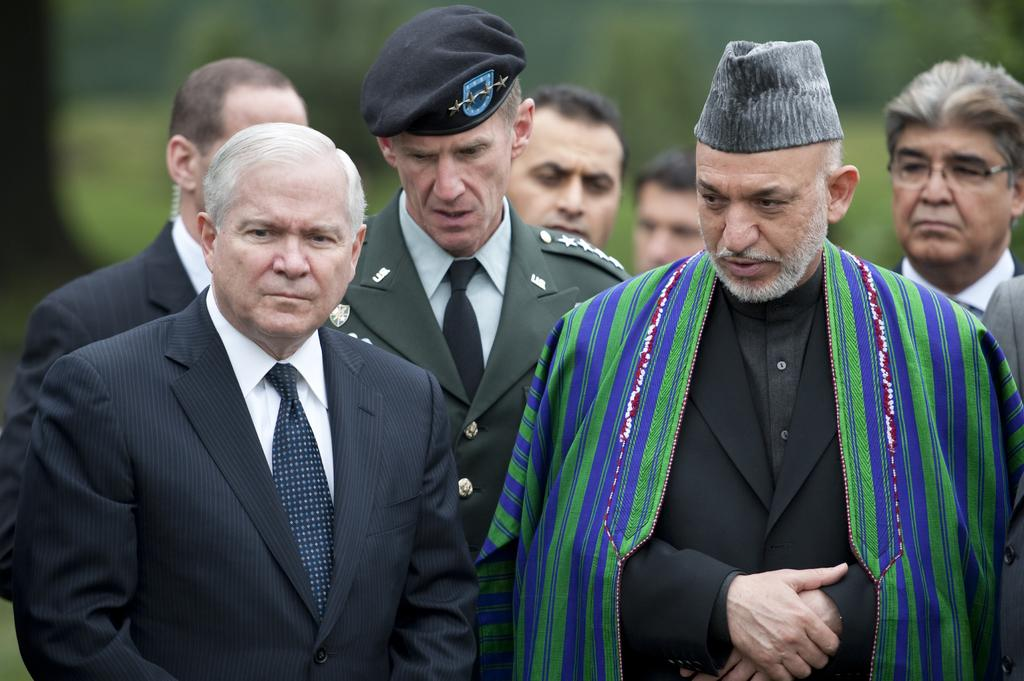What can be seen in the front of the image? There are people in the front of the image. What are two of the people wearing? Two of the people are wearing caps. What is one person wearing that is different from the others? One person is wearing a shawl. How would you describe the background of the image? The background of the image is blurred. What type of horn can be heard in the image? There is no horn present in the image, and therefore no sound can be heard. What type of oil is being used by the people in the image? There is no indication of oil being used in the image. 